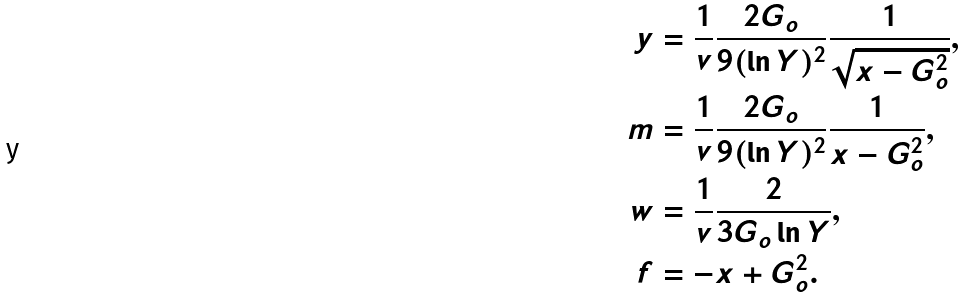Convert formula to latex. <formula><loc_0><loc_0><loc_500><loc_500>y & = \frac { 1 } { v } \frac { 2 G _ { o } } { 9 ( \ln Y ) ^ { 2 } } \frac { 1 } { \sqrt { x - G _ { o } ^ { 2 } } } , \\ m & = \frac { 1 } { v } \frac { 2 G _ { o } } { 9 ( \ln Y ) ^ { 2 } } \frac { 1 } { x - G _ { o } ^ { 2 } } , \\ w & = \frac { 1 } { v } \frac { 2 } { 3 G _ { o } \ln Y } , \\ f & = - x + G _ { o } ^ { 2 } .</formula> 